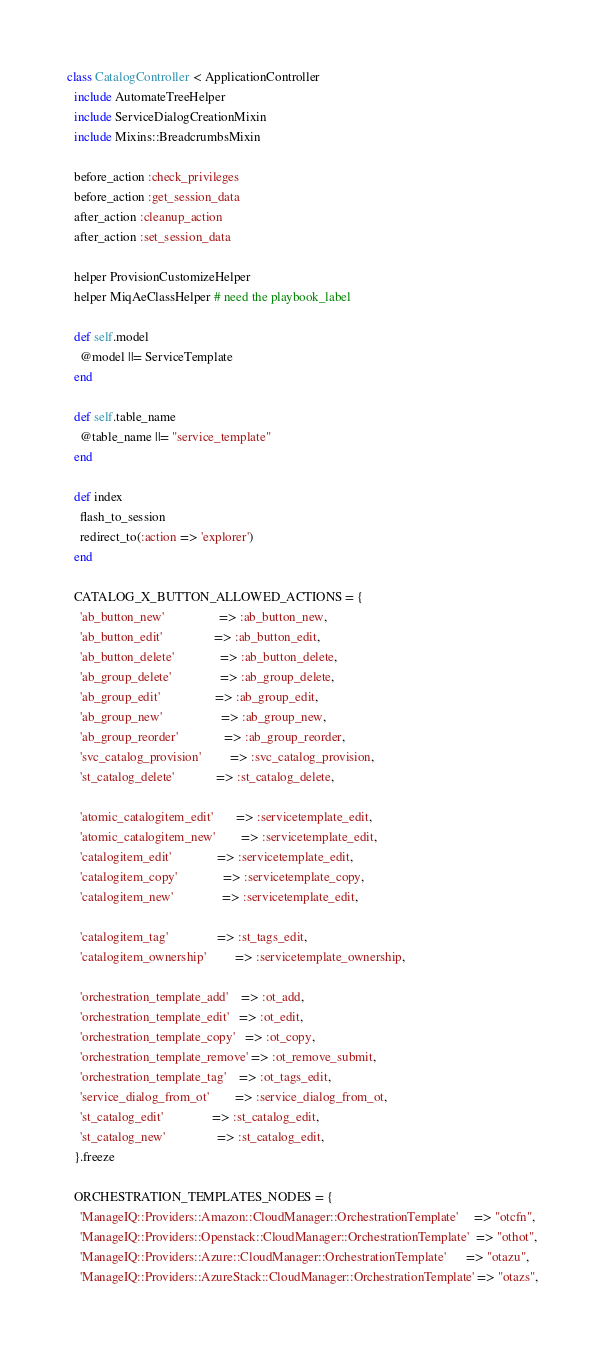<code> <loc_0><loc_0><loc_500><loc_500><_Ruby_>class CatalogController < ApplicationController
  include AutomateTreeHelper
  include ServiceDialogCreationMixin
  include Mixins::BreadcrumbsMixin

  before_action :check_privileges
  before_action :get_session_data
  after_action :cleanup_action
  after_action :set_session_data

  helper ProvisionCustomizeHelper
  helper MiqAeClassHelper # need the playbook_label

  def self.model
    @model ||= ServiceTemplate
  end

  def self.table_name
    @table_name ||= "service_template"
  end

  def index
    flash_to_session
    redirect_to(:action => 'explorer')
  end

  CATALOG_X_BUTTON_ALLOWED_ACTIONS = {
    'ab_button_new'                 => :ab_button_new,
    'ab_button_edit'                => :ab_button_edit,
    'ab_button_delete'              => :ab_button_delete,
    'ab_group_delete'               => :ab_group_delete,
    'ab_group_edit'                 => :ab_group_edit,
    'ab_group_new'                  => :ab_group_new,
    'ab_group_reorder'              => :ab_group_reorder,
    'svc_catalog_provision'         => :svc_catalog_provision,
    'st_catalog_delete'             => :st_catalog_delete,

    'atomic_catalogitem_edit'       => :servicetemplate_edit,
    'atomic_catalogitem_new'        => :servicetemplate_edit,
    'catalogitem_edit'              => :servicetemplate_edit,
    'catalogitem_copy'              => :servicetemplate_copy,
    'catalogitem_new'               => :servicetemplate_edit,

    'catalogitem_tag'               => :st_tags_edit,
    'catalogitem_ownership'         => :servicetemplate_ownership,

    'orchestration_template_add'    => :ot_add,
    'orchestration_template_edit'   => :ot_edit,
    'orchestration_template_copy'   => :ot_copy,
    'orchestration_template_remove' => :ot_remove_submit,
    'orchestration_template_tag'    => :ot_tags_edit,
    'service_dialog_from_ot'        => :service_dialog_from_ot,
    'st_catalog_edit'               => :st_catalog_edit,
    'st_catalog_new'                => :st_catalog_edit,
  }.freeze

  ORCHESTRATION_TEMPLATES_NODES = {
    'ManageIQ::Providers::Amazon::CloudManager::OrchestrationTemplate'     => "otcfn",
    'ManageIQ::Providers::Openstack::CloudManager::OrchestrationTemplate'  => "othot",
    'ManageIQ::Providers::Azure::CloudManager::OrchestrationTemplate'      => "otazu",
    'ManageIQ::Providers::AzureStack::CloudManager::OrchestrationTemplate' => "otazs",</code> 